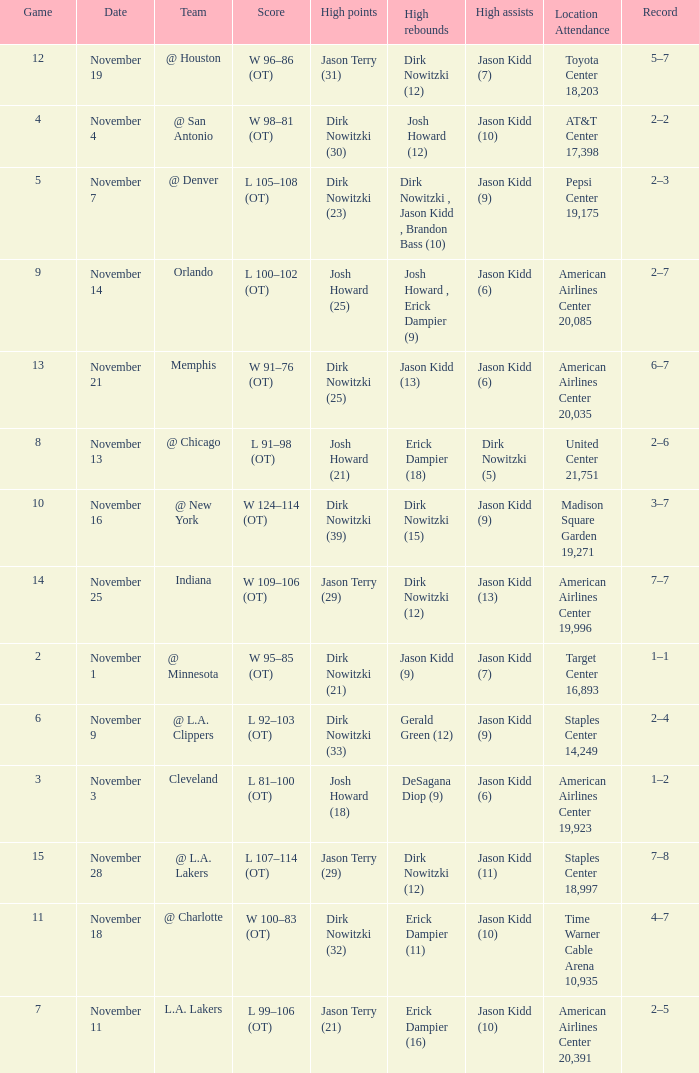What was the record on November 7? 1.0. 